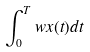Convert formula to latex. <formula><loc_0><loc_0><loc_500><loc_500>\int _ { 0 } ^ { T } w x ( t ) d t</formula> 